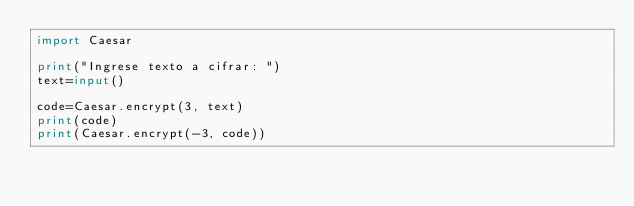<code> <loc_0><loc_0><loc_500><loc_500><_Python_>import Caesar

print("Ingrese texto a cifrar: ")
text=input()

code=Caesar.encrypt(3, text)
print(code)
print(Caesar.encrypt(-3, code))</code> 